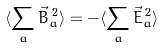Convert formula to latex. <formula><loc_0><loc_0><loc_500><loc_500>\langle \sum _ { a } \vec { B } _ { a } ^ { \, 2 } \rangle = - \langle \sum _ { a } \vec { E } _ { a } ^ { \, 2 } \rangle</formula> 